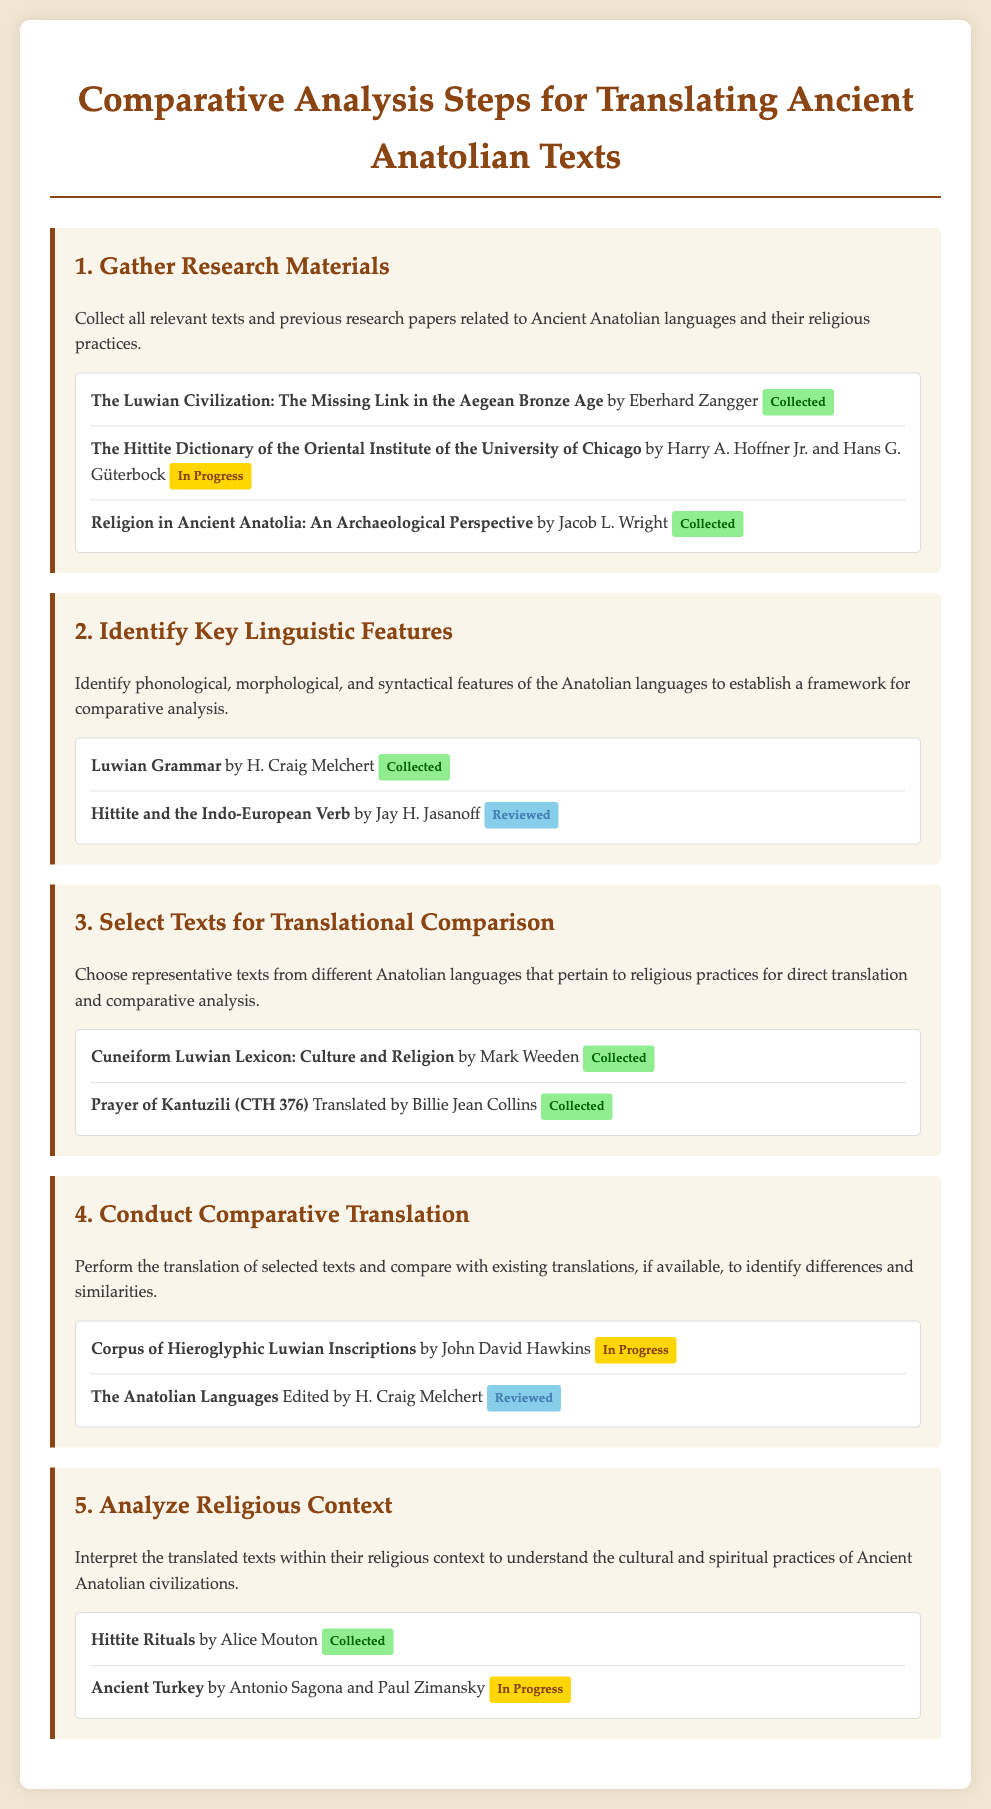what is the title of the first step? The document lists the title of the first step as "Gather Research Materials."
Answer: Gather Research Materials who is the author of "Hittite and the Indo-European Verb"? This source is attributed to Jay H. Jasanoff, as mentioned in the document.
Answer: Jay H. Jasanoff what is the status of "The Hittite Dictionary of the Oriental Institute of the University of Chicago"? The document indicates that the status of this source is "In Progress."
Answer: In Progress how many sources are listed under "Analyze Religious Context"? There are two sources listed for this step in the document.
Answer: 2 which step involves "Conduct Comparative Translation"? This step is the fourth in the checklist, as stated in the document.
Answer: Fourth who translated the "Prayer of Kantuzili (CTH 376)"? Billie Jean Collins is noted as the translator of this work in the document.
Answer: Billie Jean Collins what is the status of "Hittite Rituals"? The document shows that this source is listed as "Collected."
Answer: Collected which author is associated with "Corpus of Hieroglyphic Luwian Inscriptions"? The author of this source is John David Hawkins, as found in the checklist.
Answer: John David Hawkins 